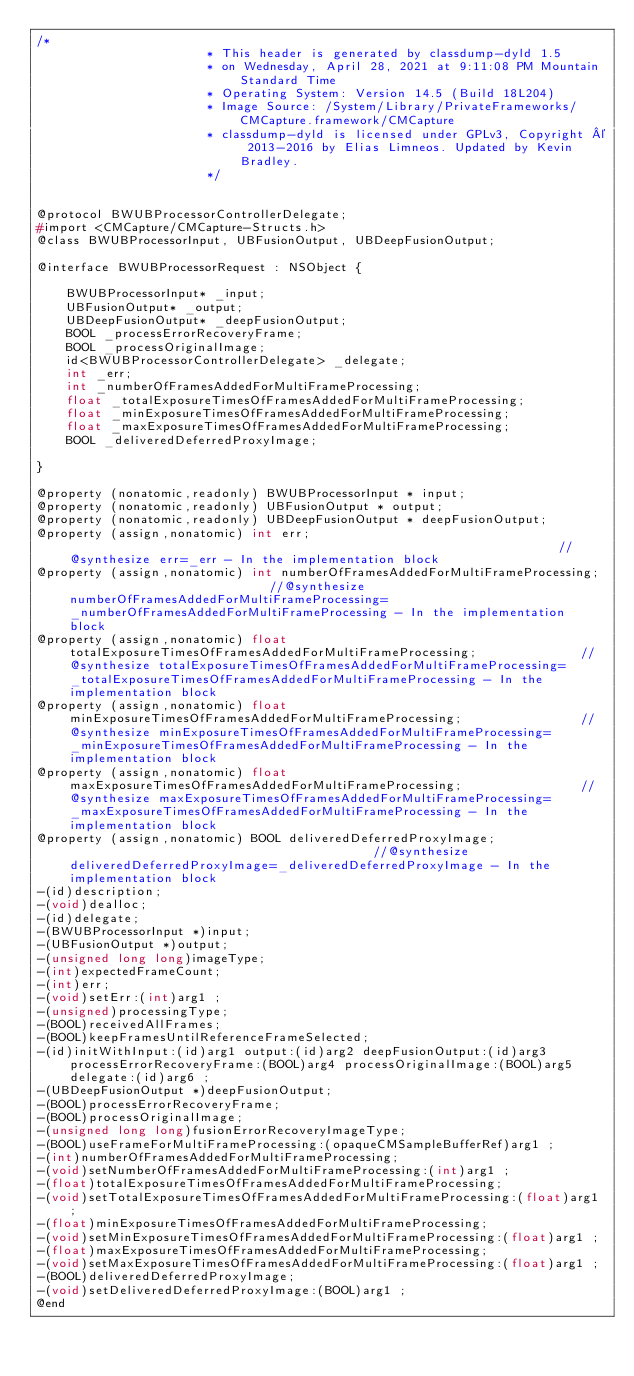Convert code to text. <code><loc_0><loc_0><loc_500><loc_500><_C_>/*
                       * This header is generated by classdump-dyld 1.5
                       * on Wednesday, April 28, 2021 at 9:11:08 PM Mountain Standard Time
                       * Operating System: Version 14.5 (Build 18L204)
                       * Image Source: /System/Library/PrivateFrameworks/CMCapture.framework/CMCapture
                       * classdump-dyld is licensed under GPLv3, Copyright © 2013-2016 by Elias Limneos. Updated by Kevin Bradley.
                       */


@protocol BWUBProcessorControllerDelegate;
#import <CMCapture/CMCapture-Structs.h>
@class BWUBProcessorInput, UBFusionOutput, UBDeepFusionOutput;

@interface BWUBProcessorRequest : NSObject {

	BWUBProcessorInput* _input;
	UBFusionOutput* _output;
	UBDeepFusionOutput* _deepFusionOutput;
	BOOL _processErrorRecoveryFrame;
	BOOL _processOriginalImage;
	id<BWUBProcessorControllerDelegate> _delegate;
	int _err;
	int _numberOfFramesAddedForMultiFrameProcessing;
	float _totalExposureTimesOfFramesAddedForMultiFrameProcessing;
	float _minExposureTimesOfFramesAddedForMultiFrameProcessing;
	float _maxExposureTimesOfFramesAddedForMultiFrameProcessing;
	BOOL _deliveredDeferredProxyImage;

}

@property (nonatomic,readonly) BWUBProcessorInput * input; 
@property (nonatomic,readonly) UBFusionOutput * output; 
@property (nonatomic,readonly) UBDeepFusionOutput * deepFusionOutput; 
@property (assign,nonatomic) int err;                                                                   //@synthesize err=_err - In the implementation block
@property (assign,nonatomic) int numberOfFramesAddedForMultiFrameProcessing;                            //@synthesize numberOfFramesAddedForMultiFrameProcessing=_numberOfFramesAddedForMultiFrameProcessing - In the implementation block
@property (assign,nonatomic) float totalExposureTimesOfFramesAddedForMultiFrameProcessing;              //@synthesize totalExposureTimesOfFramesAddedForMultiFrameProcessing=_totalExposureTimesOfFramesAddedForMultiFrameProcessing - In the implementation block
@property (assign,nonatomic) float minExposureTimesOfFramesAddedForMultiFrameProcessing;                //@synthesize minExposureTimesOfFramesAddedForMultiFrameProcessing=_minExposureTimesOfFramesAddedForMultiFrameProcessing - In the implementation block
@property (assign,nonatomic) float maxExposureTimesOfFramesAddedForMultiFrameProcessing;                //@synthesize maxExposureTimesOfFramesAddedForMultiFrameProcessing=_maxExposureTimesOfFramesAddedForMultiFrameProcessing - In the implementation block
@property (assign,nonatomic) BOOL deliveredDeferredProxyImage;                                          //@synthesize deliveredDeferredProxyImage=_deliveredDeferredProxyImage - In the implementation block
-(id)description;
-(void)dealloc;
-(id)delegate;
-(BWUBProcessorInput *)input;
-(UBFusionOutput *)output;
-(unsigned long long)imageType;
-(int)expectedFrameCount;
-(int)err;
-(void)setErr:(int)arg1 ;
-(unsigned)processingType;
-(BOOL)receivedAllFrames;
-(BOOL)keepFramesUntilReferenceFrameSelected;
-(id)initWithInput:(id)arg1 output:(id)arg2 deepFusionOutput:(id)arg3 processErrorRecoveryFrame:(BOOL)arg4 processOriginalImage:(BOOL)arg5 delegate:(id)arg6 ;
-(UBDeepFusionOutput *)deepFusionOutput;
-(BOOL)processErrorRecoveryFrame;
-(BOOL)processOriginalImage;
-(unsigned long long)fusionErrorRecoveryImageType;
-(BOOL)useFrameForMultiFrameProcessing:(opaqueCMSampleBufferRef)arg1 ;
-(int)numberOfFramesAddedForMultiFrameProcessing;
-(void)setNumberOfFramesAddedForMultiFrameProcessing:(int)arg1 ;
-(float)totalExposureTimesOfFramesAddedForMultiFrameProcessing;
-(void)setTotalExposureTimesOfFramesAddedForMultiFrameProcessing:(float)arg1 ;
-(float)minExposureTimesOfFramesAddedForMultiFrameProcessing;
-(void)setMinExposureTimesOfFramesAddedForMultiFrameProcessing:(float)arg1 ;
-(float)maxExposureTimesOfFramesAddedForMultiFrameProcessing;
-(void)setMaxExposureTimesOfFramesAddedForMultiFrameProcessing:(float)arg1 ;
-(BOOL)deliveredDeferredProxyImage;
-(void)setDeliveredDeferredProxyImage:(BOOL)arg1 ;
@end

</code> 